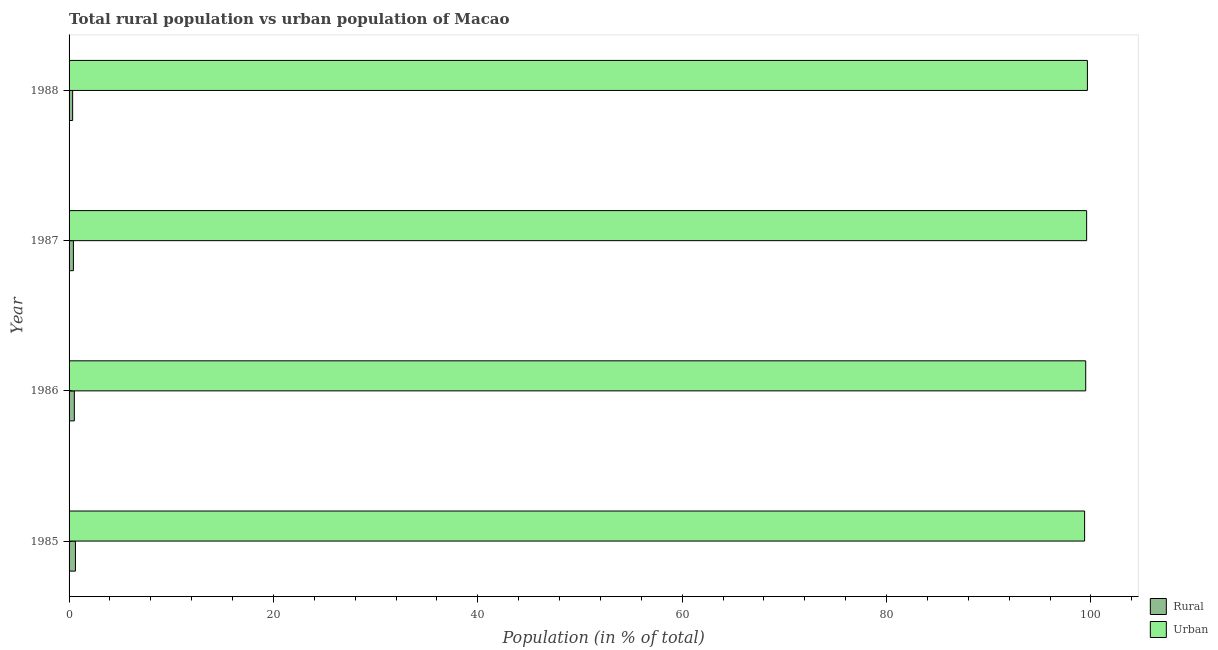How many groups of bars are there?
Ensure brevity in your answer.  4. Are the number of bars per tick equal to the number of legend labels?
Give a very brief answer. Yes. How many bars are there on the 3rd tick from the top?
Provide a succinct answer. 2. What is the label of the 2nd group of bars from the top?
Offer a very short reply. 1987. In how many cases, is the number of bars for a given year not equal to the number of legend labels?
Provide a short and direct response. 0. What is the rural population in 1987?
Keep it short and to the point. 0.42. Across all years, what is the maximum urban population?
Provide a short and direct response. 99.65. Across all years, what is the minimum rural population?
Ensure brevity in your answer.  0.35. In which year was the urban population maximum?
Ensure brevity in your answer.  1988. In which year was the urban population minimum?
Give a very brief answer. 1985. What is the total rural population in the graph?
Your answer should be compact. 1.91. What is the difference between the urban population in 1985 and that in 1987?
Keep it short and to the point. -0.2. What is the difference between the rural population in 1987 and the urban population in 1986?
Offer a terse response. -99.06. What is the average rural population per year?
Give a very brief answer. 0.48. In the year 1988, what is the difference between the rural population and urban population?
Provide a succinct answer. -99.3. In how many years, is the rural population greater than 8 %?
Give a very brief answer. 0. What is the ratio of the rural population in 1986 to that in 1988?
Keep it short and to the point. 1.47. Is the difference between the rural population in 1985 and 1988 greater than the difference between the urban population in 1985 and 1988?
Keep it short and to the point. Yes. What is the difference between the highest and the second highest rural population?
Give a very brief answer. 0.11. What is the difference between the highest and the lowest urban population?
Provide a short and direct response. 0.27. Is the sum of the rural population in 1986 and 1987 greater than the maximum urban population across all years?
Ensure brevity in your answer.  No. What does the 1st bar from the top in 1985 represents?
Provide a succinct answer. Urban. What does the 2nd bar from the bottom in 1986 represents?
Offer a very short reply. Urban. How many years are there in the graph?
Your answer should be compact. 4. What is the difference between two consecutive major ticks on the X-axis?
Ensure brevity in your answer.  20. Does the graph contain any zero values?
Your answer should be compact. No. Where does the legend appear in the graph?
Keep it short and to the point. Bottom right. What is the title of the graph?
Keep it short and to the point. Total rural population vs urban population of Macao. Does "From human activities" appear as one of the legend labels in the graph?
Ensure brevity in your answer.  No. What is the label or title of the X-axis?
Give a very brief answer. Population (in % of total). What is the label or title of the Y-axis?
Make the answer very short. Year. What is the Population (in % of total) in Rural in 1985?
Give a very brief answer. 0.62. What is the Population (in % of total) in Urban in 1985?
Ensure brevity in your answer.  99.38. What is the Population (in % of total) in Rural in 1986?
Your response must be concise. 0.51. What is the Population (in % of total) of Urban in 1986?
Your response must be concise. 99.49. What is the Population (in % of total) of Rural in 1987?
Your answer should be compact. 0.42. What is the Population (in % of total) of Urban in 1987?
Offer a terse response. 99.58. What is the Population (in % of total) of Rural in 1988?
Your response must be concise. 0.35. What is the Population (in % of total) in Urban in 1988?
Provide a short and direct response. 99.65. Across all years, what is the maximum Population (in % of total) in Rural?
Keep it short and to the point. 0.62. Across all years, what is the maximum Population (in % of total) of Urban?
Provide a succinct answer. 99.65. Across all years, what is the minimum Population (in % of total) of Rural?
Your answer should be compact. 0.35. Across all years, what is the minimum Population (in % of total) in Urban?
Give a very brief answer. 99.38. What is the total Population (in % of total) of Rural in the graph?
Provide a succinct answer. 1.91. What is the total Population (in % of total) in Urban in the graph?
Your answer should be compact. 398.09. What is the difference between the Population (in % of total) of Rural in 1985 and that in 1986?
Offer a very short reply. 0.11. What is the difference between the Population (in % of total) of Urban in 1985 and that in 1986?
Offer a terse response. -0.11. What is the difference between the Population (in % of total) of Rural in 1985 and that in 1987?
Ensure brevity in your answer.  0.2. What is the difference between the Population (in % of total) of Urban in 1985 and that in 1987?
Offer a very short reply. -0.2. What is the difference between the Population (in % of total) in Rural in 1985 and that in 1988?
Provide a short and direct response. 0.27. What is the difference between the Population (in % of total) of Urban in 1985 and that in 1988?
Offer a terse response. -0.27. What is the difference between the Population (in % of total) of Rural in 1986 and that in 1987?
Make the answer very short. 0.09. What is the difference between the Population (in % of total) of Urban in 1986 and that in 1987?
Offer a very short reply. -0.09. What is the difference between the Population (in % of total) of Rural in 1986 and that in 1988?
Ensure brevity in your answer.  0.17. What is the difference between the Population (in % of total) of Urban in 1986 and that in 1988?
Provide a short and direct response. -0.17. What is the difference between the Population (in % of total) of Rural in 1987 and that in 1988?
Keep it short and to the point. 0.07. What is the difference between the Population (in % of total) in Urban in 1987 and that in 1988?
Provide a short and direct response. -0.07. What is the difference between the Population (in % of total) in Rural in 1985 and the Population (in % of total) in Urban in 1986?
Your response must be concise. -98.86. What is the difference between the Population (in % of total) of Rural in 1985 and the Population (in % of total) of Urban in 1987?
Offer a terse response. -98.95. What is the difference between the Population (in % of total) of Rural in 1985 and the Population (in % of total) of Urban in 1988?
Offer a very short reply. -99.03. What is the difference between the Population (in % of total) of Rural in 1986 and the Population (in % of total) of Urban in 1987?
Your answer should be compact. -99.06. What is the difference between the Population (in % of total) of Rural in 1986 and the Population (in % of total) of Urban in 1988?
Your response must be concise. -99.14. What is the difference between the Population (in % of total) in Rural in 1987 and the Population (in % of total) in Urban in 1988?
Your response must be concise. -99.23. What is the average Population (in % of total) in Rural per year?
Keep it short and to the point. 0.48. What is the average Population (in % of total) of Urban per year?
Your answer should be very brief. 99.52. In the year 1985, what is the difference between the Population (in % of total) in Rural and Population (in % of total) in Urban?
Provide a succinct answer. -98.75. In the year 1986, what is the difference between the Population (in % of total) of Rural and Population (in % of total) of Urban?
Ensure brevity in your answer.  -98.97. In the year 1987, what is the difference between the Population (in % of total) of Rural and Population (in % of total) of Urban?
Provide a short and direct response. -99.15. In the year 1988, what is the difference between the Population (in % of total) in Rural and Population (in % of total) in Urban?
Keep it short and to the point. -99.3. What is the ratio of the Population (in % of total) in Rural in 1985 to that in 1986?
Provide a short and direct response. 1.21. What is the ratio of the Population (in % of total) in Rural in 1985 to that in 1987?
Your answer should be very brief. 1.47. What is the ratio of the Population (in % of total) of Urban in 1985 to that in 1987?
Give a very brief answer. 1. What is the ratio of the Population (in % of total) of Rural in 1985 to that in 1988?
Offer a terse response. 1.79. What is the ratio of the Population (in % of total) of Rural in 1986 to that in 1987?
Make the answer very short. 1.21. What is the ratio of the Population (in % of total) in Rural in 1986 to that in 1988?
Make the answer very short. 1.47. What is the ratio of the Population (in % of total) of Urban in 1986 to that in 1988?
Offer a very short reply. 1. What is the ratio of the Population (in % of total) of Rural in 1987 to that in 1988?
Your answer should be very brief. 1.21. What is the difference between the highest and the second highest Population (in % of total) of Rural?
Provide a succinct answer. 0.11. What is the difference between the highest and the second highest Population (in % of total) in Urban?
Provide a succinct answer. 0.07. What is the difference between the highest and the lowest Population (in % of total) in Rural?
Provide a short and direct response. 0.27. What is the difference between the highest and the lowest Population (in % of total) of Urban?
Offer a terse response. 0.27. 